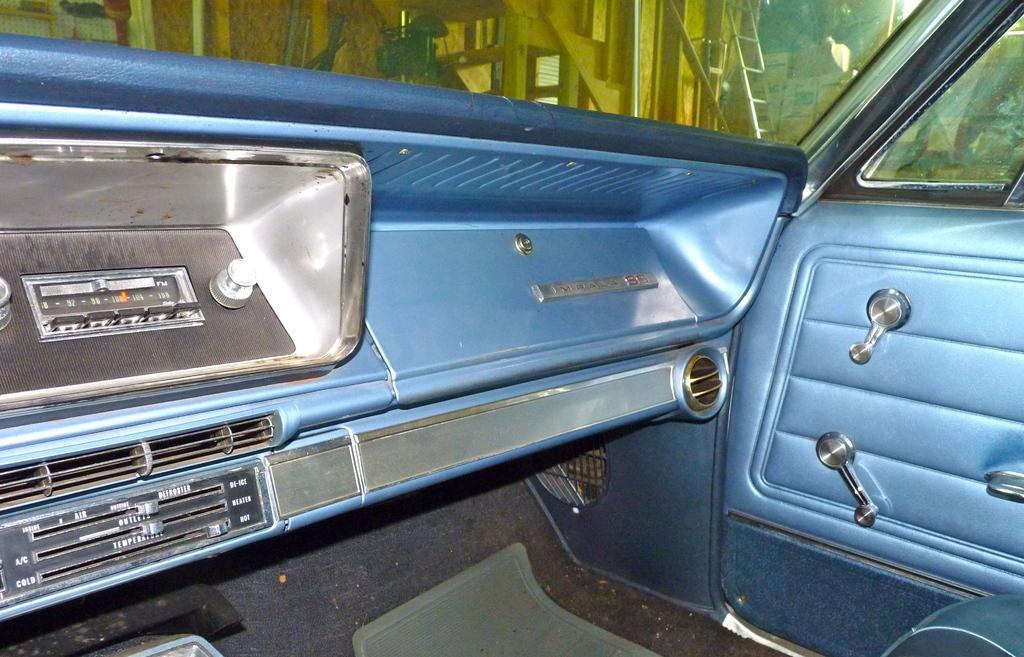Can you describe this image briefly? In this image I can see inside view of a vehicle. In the background I can see a ladder and few boxes. 